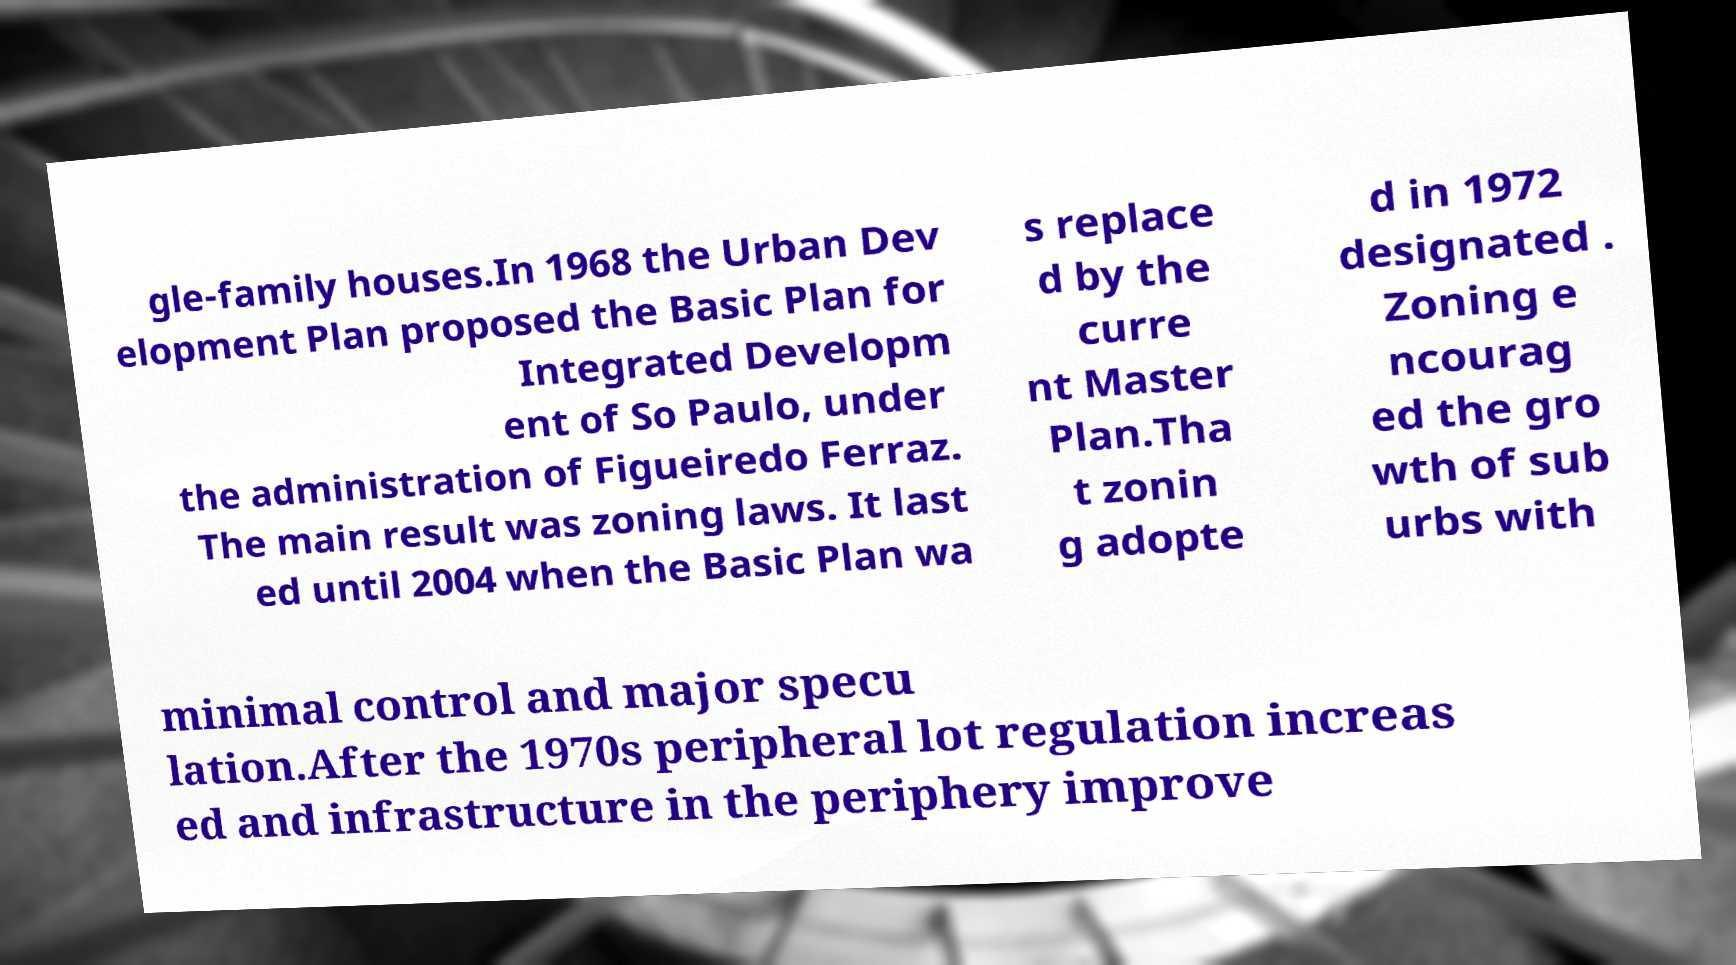Please identify and transcribe the text found in this image. gle-family houses.In 1968 the Urban Dev elopment Plan proposed the Basic Plan for Integrated Developm ent of So Paulo, under the administration of Figueiredo Ferraz. The main result was zoning laws. It last ed until 2004 when the Basic Plan wa s replace d by the curre nt Master Plan.Tha t zonin g adopte d in 1972 designated . Zoning e ncourag ed the gro wth of sub urbs with minimal control and major specu lation.After the 1970s peripheral lot regulation increas ed and infrastructure in the periphery improve 